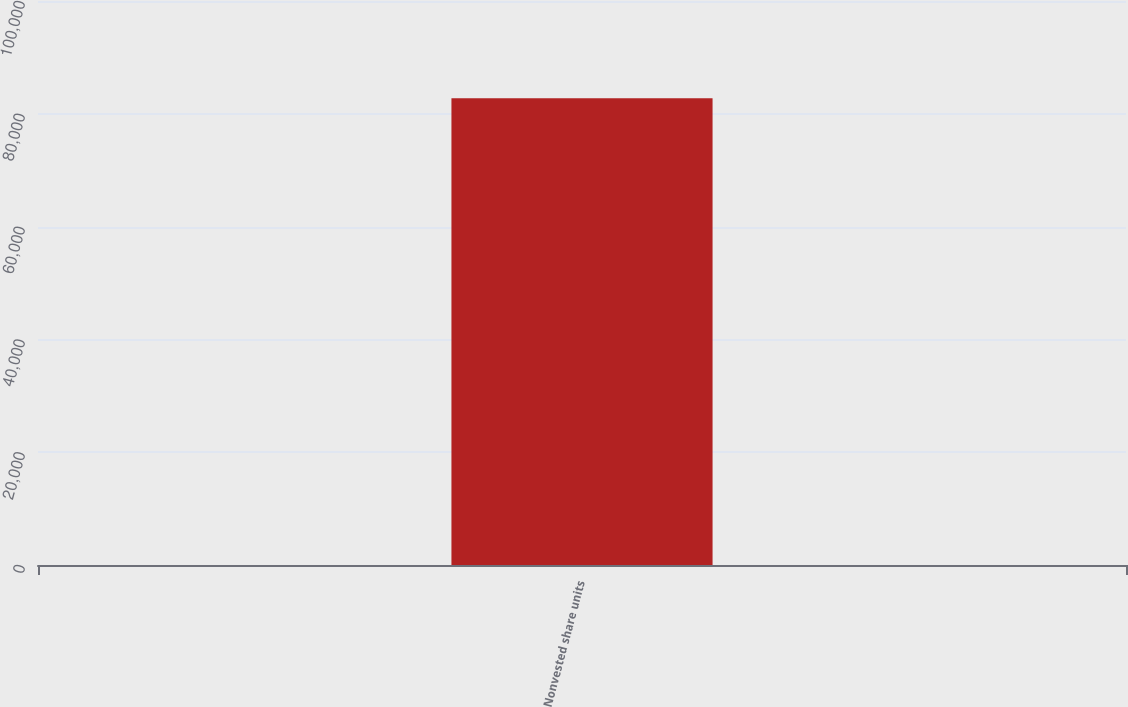Convert chart to OTSL. <chart><loc_0><loc_0><loc_500><loc_500><bar_chart><fcel>Nonvested share units<nl><fcel>82742<nl></chart> 